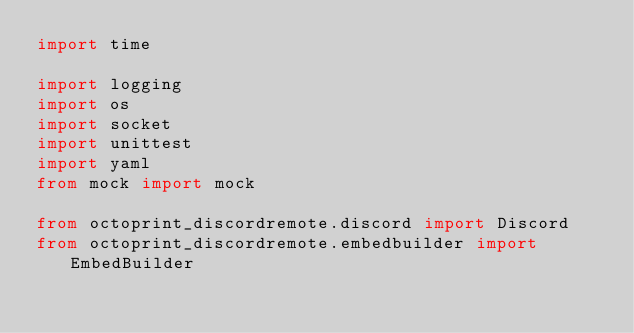Convert code to text. <code><loc_0><loc_0><loc_500><loc_500><_Python_>import time

import logging
import os
import socket
import unittest
import yaml
from mock import mock

from octoprint_discordremote.discord import Discord
from octoprint_discordremote.embedbuilder import EmbedBuilder</code> 